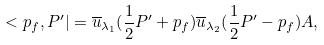<formula> <loc_0><loc_0><loc_500><loc_500>< p _ { f } , P ^ { \prime } | = \overline { u } _ { \lambda _ { 1 } } ( \frac { 1 } { 2 } { P } ^ { \prime } + { p } _ { f } ) \overline { u } _ { \lambda _ { 2 } } ( \frac { 1 } { 2 } { P } ^ { \prime } - { p } _ { f } ) A ,</formula> 